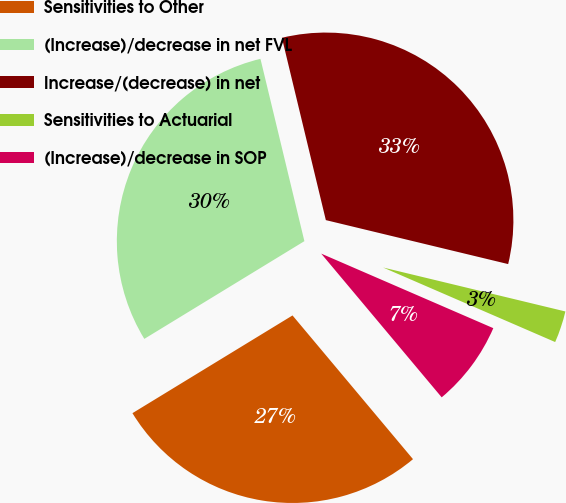<chart> <loc_0><loc_0><loc_500><loc_500><pie_chart><fcel>Sensitivities to Other<fcel>(Increase)/decrease in net FVL<fcel>Increase/(decrease) in net<fcel>Sensitivities to Actuarial<fcel>(Increase)/decrease in SOP<nl><fcel>27.38%<fcel>29.96%<fcel>32.53%<fcel>2.74%<fcel>7.39%<nl></chart> 